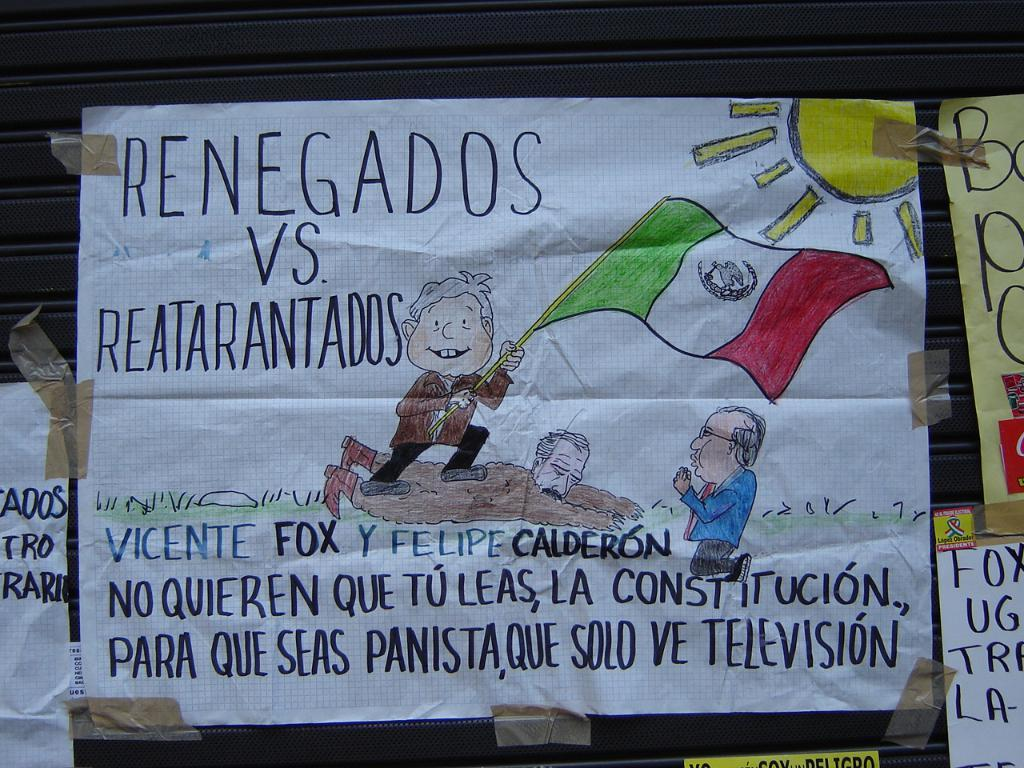<image>
Create a compact narrative representing the image presented. A hand made sign that is written in Spanish and references Renegados vs. Reatarantados. 